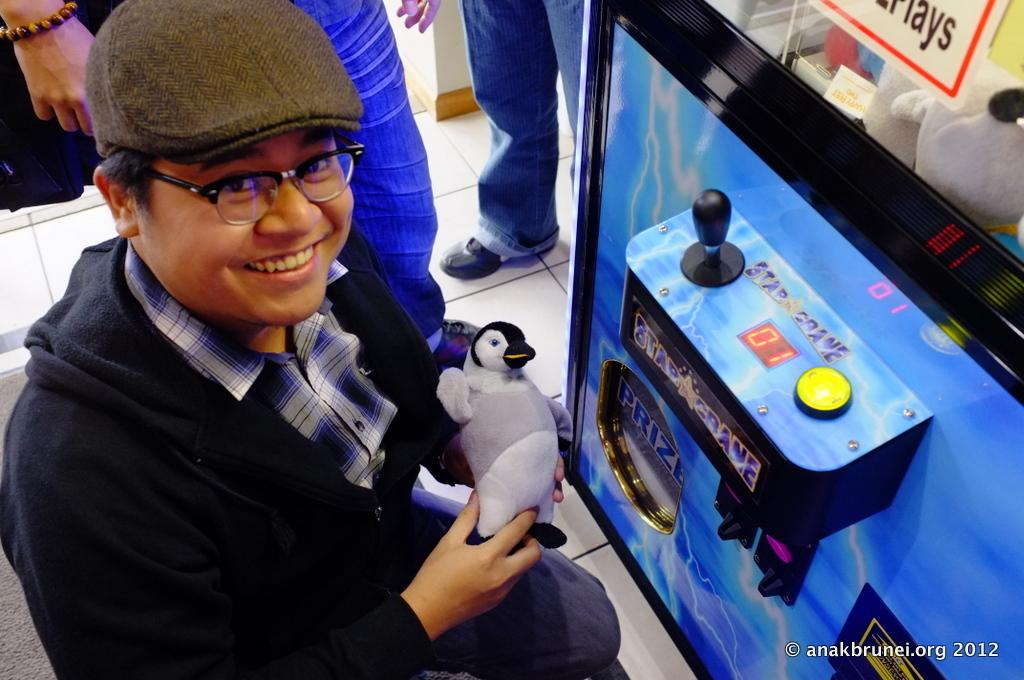What is the man in the image doing? The man is standing in the image and holding a toy. Are there any other people in the image besides the man? Yes, there are other people standing in the image. What type of zebra can be seen in the room in the image? There is no zebra present in the image, and the image does not depict a room. 